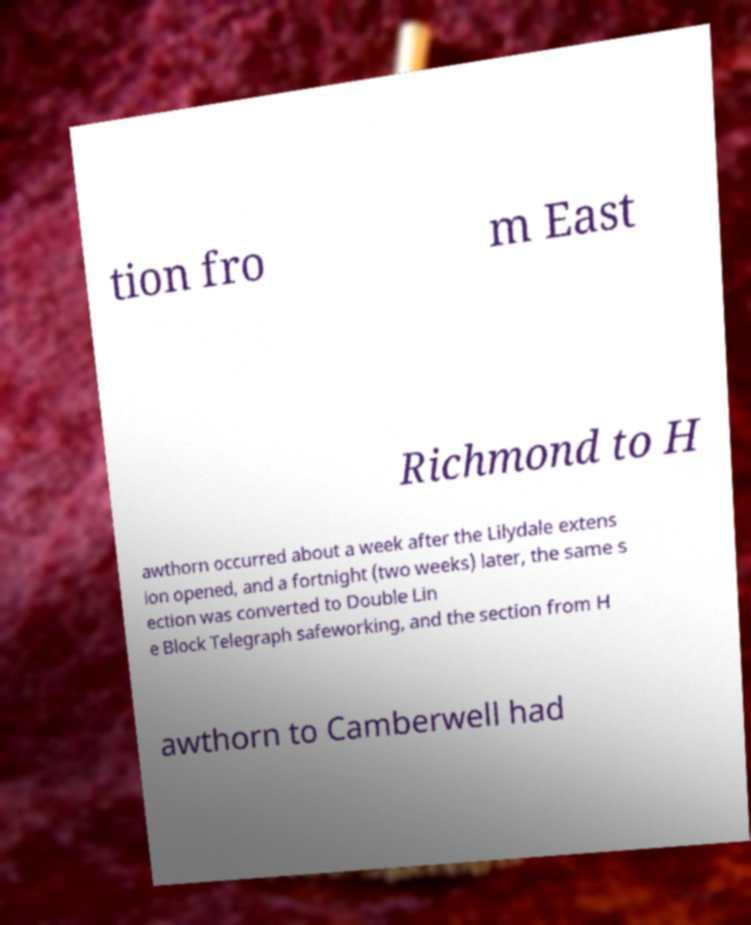Could you assist in decoding the text presented in this image and type it out clearly? tion fro m East Richmond to H awthorn occurred about a week after the Lilydale extens ion opened, and a fortnight (two weeks) later, the same s ection was converted to Double Lin e Block Telegraph safeworking, and the section from H awthorn to Camberwell had 